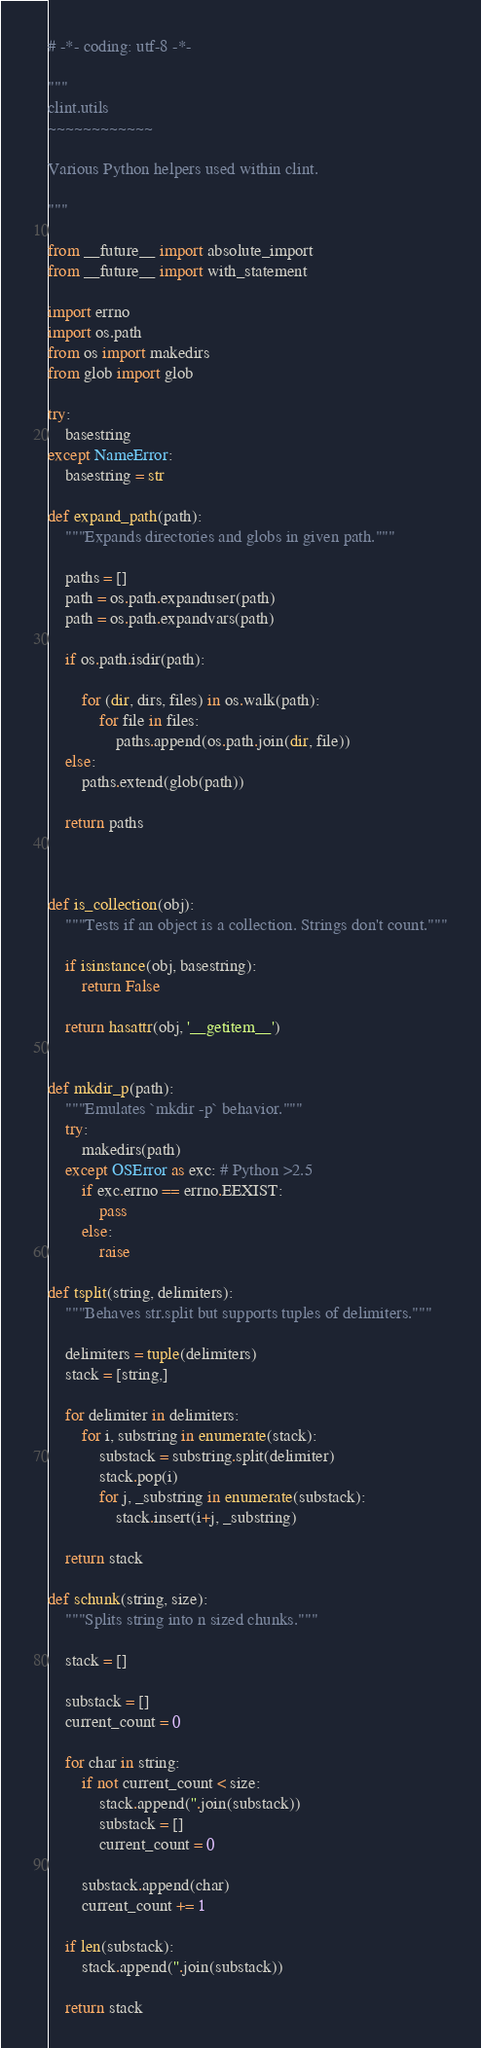Convert code to text. <code><loc_0><loc_0><loc_500><loc_500><_Python_># -*- coding: utf-8 -*-

"""
clint.utils
~~~~~~~~~~~~

Various Python helpers used within clint.

"""

from __future__ import absolute_import
from __future__ import with_statement

import errno
import os.path
from os import makedirs
from glob import glob

try:
    basestring
except NameError:
    basestring = str

def expand_path(path):
    """Expands directories and globs in given path."""

    paths = []
    path = os.path.expanduser(path)
    path = os.path.expandvars(path)

    if os.path.isdir(path):

        for (dir, dirs, files) in os.walk(path):
            for file in files:
                paths.append(os.path.join(dir, file))
    else:
        paths.extend(glob(path))

    return paths



def is_collection(obj):
    """Tests if an object is a collection. Strings don't count."""

    if isinstance(obj, basestring):
        return False

    return hasattr(obj, '__getitem__')


def mkdir_p(path):
    """Emulates `mkdir -p` behavior."""
    try:
        makedirs(path)
    except OSError as exc: # Python >2.5
        if exc.errno == errno.EEXIST:
            pass
        else:
            raise

def tsplit(string, delimiters):
    """Behaves str.split but supports tuples of delimiters."""

    delimiters = tuple(delimiters)
    stack = [string,]

    for delimiter in delimiters:
        for i, substring in enumerate(stack):
            substack = substring.split(delimiter)
            stack.pop(i)
            for j, _substring in enumerate(substack):
                stack.insert(i+j, _substring)

    return stack

def schunk(string, size):
    """Splits string into n sized chunks."""

    stack = []

    substack = []
    current_count = 0

    for char in string:
        if not current_count < size:
            stack.append(''.join(substack))
            substack = []
            current_count = 0

        substack.append(char)
        current_count += 1

    if len(substack):
        stack.append(''.join(substack))

    return stack
</code> 